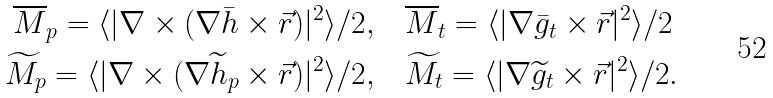<formula> <loc_0><loc_0><loc_500><loc_500>\overline { M } _ { p } = \langle | \nabla \times ( \nabla \bar { h } \times \vec { r } ) | ^ { 2 } \rangle / 2 , \quad & \overline { M } _ { t } = \langle | \nabla \bar { g } _ { t } \times \vec { r } | ^ { 2 } \rangle / 2 \\ \widetilde { M } _ { p } = \langle | \nabla \times ( \nabla \widetilde { h } _ { p } \times \vec { r } ) | ^ { 2 } \rangle / 2 , \quad & \widetilde { M } _ { t } = \langle | \nabla \widetilde { g } _ { t } \times \vec { r } | ^ { 2 } \rangle / 2 .</formula> 